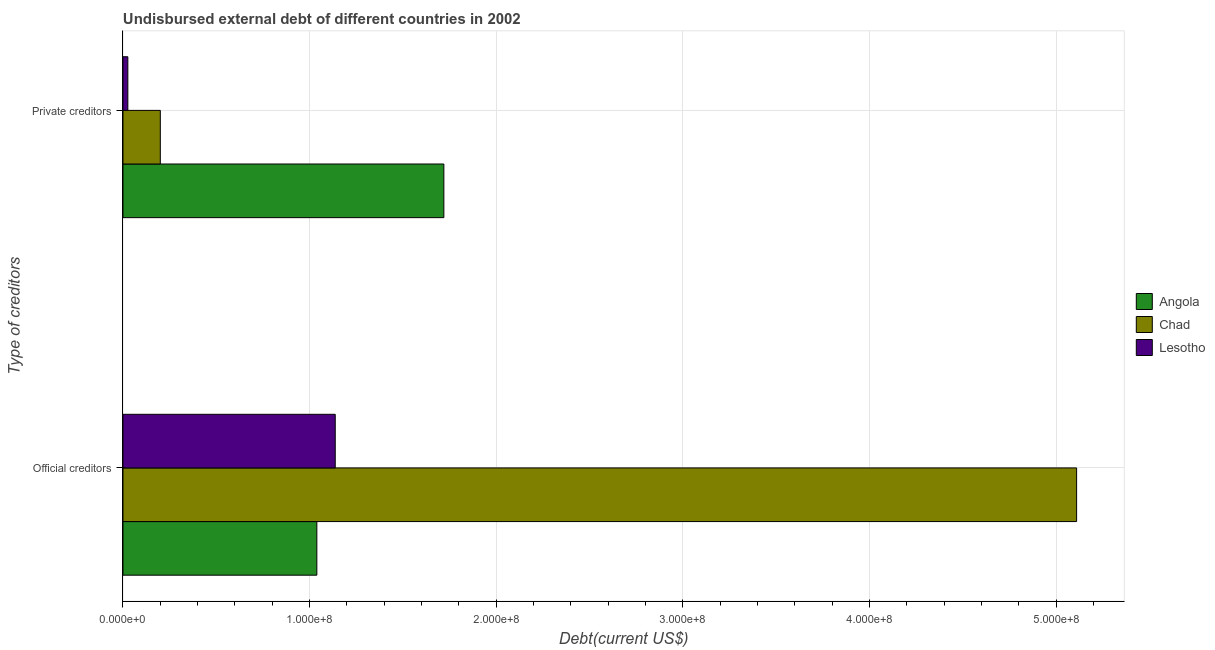How many groups of bars are there?
Offer a very short reply. 2. How many bars are there on the 1st tick from the top?
Offer a terse response. 3. How many bars are there on the 1st tick from the bottom?
Provide a succinct answer. 3. What is the label of the 1st group of bars from the top?
Your answer should be very brief. Private creditors. What is the undisbursed external debt of official creditors in Angola?
Provide a succinct answer. 1.04e+08. Across all countries, what is the maximum undisbursed external debt of private creditors?
Provide a succinct answer. 1.72e+08. Across all countries, what is the minimum undisbursed external debt of official creditors?
Make the answer very short. 1.04e+08. In which country was the undisbursed external debt of official creditors maximum?
Provide a short and direct response. Chad. In which country was the undisbursed external debt of private creditors minimum?
Your answer should be very brief. Lesotho. What is the total undisbursed external debt of private creditors in the graph?
Provide a succinct answer. 1.95e+08. What is the difference between the undisbursed external debt of private creditors in Angola and that in Lesotho?
Provide a short and direct response. 1.69e+08. What is the difference between the undisbursed external debt of official creditors in Lesotho and the undisbursed external debt of private creditors in Angola?
Make the answer very short. -5.82e+07. What is the average undisbursed external debt of official creditors per country?
Your answer should be compact. 2.43e+08. What is the difference between the undisbursed external debt of private creditors and undisbursed external debt of official creditors in Angola?
Your response must be concise. 6.81e+07. What is the ratio of the undisbursed external debt of official creditors in Lesotho to that in Chad?
Ensure brevity in your answer.  0.22. What does the 1st bar from the top in Official creditors represents?
Your answer should be compact. Lesotho. What does the 2nd bar from the bottom in Official creditors represents?
Ensure brevity in your answer.  Chad. Are all the bars in the graph horizontal?
Your answer should be compact. Yes. How many countries are there in the graph?
Offer a very short reply. 3. Does the graph contain any zero values?
Offer a terse response. No. How many legend labels are there?
Your answer should be compact. 3. What is the title of the graph?
Give a very brief answer. Undisbursed external debt of different countries in 2002. What is the label or title of the X-axis?
Make the answer very short. Debt(current US$). What is the label or title of the Y-axis?
Your answer should be very brief. Type of creditors. What is the Debt(current US$) of Angola in Official creditors?
Provide a short and direct response. 1.04e+08. What is the Debt(current US$) in Chad in Official creditors?
Your answer should be very brief. 5.11e+08. What is the Debt(current US$) in Lesotho in Official creditors?
Give a very brief answer. 1.14e+08. What is the Debt(current US$) of Angola in Private creditors?
Give a very brief answer. 1.72e+08. What is the Debt(current US$) in Chad in Private creditors?
Provide a succinct answer. 2.00e+07. What is the Debt(current US$) of Lesotho in Private creditors?
Your answer should be compact. 2.60e+06. Across all Type of creditors, what is the maximum Debt(current US$) of Angola?
Offer a terse response. 1.72e+08. Across all Type of creditors, what is the maximum Debt(current US$) of Chad?
Provide a short and direct response. 5.11e+08. Across all Type of creditors, what is the maximum Debt(current US$) in Lesotho?
Your answer should be compact. 1.14e+08. Across all Type of creditors, what is the minimum Debt(current US$) of Angola?
Your answer should be compact. 1.04e+08. Across all Type of creditors, what is the minimum Debt(current US$) in Chad?
Provide a succinct answer. 2.00e+07. Across all Type of creditors, what is the minimum Debt(current US$) of Lesotho?
Make the answer very short. 2.60e+06. What is the total Debt(current US$) of Angola in the graph?
Make the answer very short. 2.76e+08. What is the total Debt(current US$) of Chad in the graph?
Keep it short and to the point. 5.31e+08. What is the total Debt(current US$) of Lesotho in the graph?
Your answer should be compact. 1.16e+08. What is the difference between the Debt(current US$) in Angola in Official creditors and that in Private creditors?
Keep it short and to the point. -6.81e+07. What is the difference between the Debt(current US$) in Chad in Official creditors and that in Private creditors?
Provide a short and direct response. 4.91e+08. What is the difference between the Debt(current US$) of Lesotho in Official creditors and that in Private creditors?
Make the answer very short. 1.11e+08. What is the difference between the Debt(current US$) of Angola in Official creditors and the Debt(current US$) of Chad in Private creditors?
Offer a very short reply. 8.39e+07. What is the difference between the Debt(current US$) in Angola in Official creditors and the Debt(current US$) in Lesotho in Private creditors?
Offer a terse response. 1.01e+08. What is the difference between the Debt(current US$) of Chad in Official creditors and the Debt(current US$) of Lesotho in Private creditors?
Your answer should be compact. 5.08e+08. What is the average Debt(current US$) in Angola per Type of creditors?
Your answer should be very brief. 1.38e+08. What is the average Debt(current US$) of Chad per Type of creditors?
Your response must be concise. 2.65e+08. What is the average Debt(current US$) of Lesotho per Type of creditors?
Your answer should be very brief. 5.82e+07. What is the difference between the Debt(current US$) in Angola and Debt(current US$) in Chad in Official creditors?
Provide a succinct answer. -4.07e+08. What is the difference between the Debt(current US$) in Angola and Debt(current US$) in Lesotho in Official creditors?
Your response must be concise. -9.86e+06. What is the difference between the Debt(current US$) of Chad and Debt(current US$) of Lesotho in Official creditors?
Provide a short and direct response. 3.97e+08. What is the difference between the Debt(current US$) in Angola and Debt(current US$) in Chad in Private creditors?
Ensure brevity in your answer.  1.52e+08. What is the difference between the Debt(current US$) of Angola and Debt(current US$) of Lesotho in Private creditors?
Your answer should be compact. 1.69e+08. What is the difference between the Debt(current US$) of Chad and Debt(current US$) of Lesotho in Private creditors?
Give a very brief answer. 1.74e+07. What is the ratio of the Debt(current US$) in Angola in Official creditors to that in Private creditors?
Ensure brevity in your answer.  0.6. What is the ratio of the Debt(current US$) in Chad in Official creditors to that in Private creditors?
Your response must be concise. 25.55. What is the ratio of the Debt(current US$) of Lesotho in Official creditors to that in Private creditors?
Offer a very short reply. 43.68. What is the difference between the highest and the second highest Debt(current US$) of Angola?
Your response must be concise. 6.81e+07. What is the difference between the highest and the second highest Debt(current US$) of Chad?
Your response must be concise. 4.91e+08. What is the difference between the highest and the second highest Debt(current US$) in Lesotho?
Your response must be concise. 1.11e+08. What is the difference between the highest and the lowest Debt(current US$) in Angola?
Keep it short and to the point. 6.81e+07. What is the difference between the highest and the lowest Debt(current US$) in Chad?
Provide a short and direct response. 4.91e+08. What is the difference between the highest and the lowest Debt(current US$) of Lesotho?
Make the answer very short. 1.11e+08. 